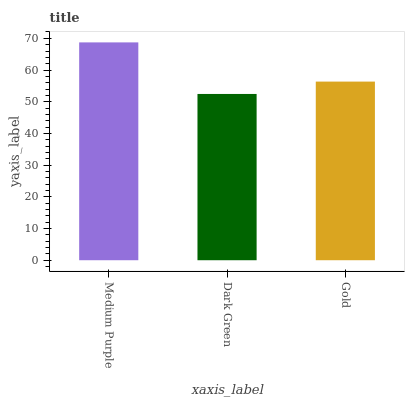Is Dark Green the minimum?
Answer yes or no. Yes. Is Medium Purple the maximum?
Answer yes or no. Yes. Is Gold the minimum?
Answer yes or no. No. Is Gold the maximum?
Answer yes or no. No. Is Gold greater than Dark Green?
Answer yes or no. Yes. Is Dark Green less than Gold?
Answer yes or no. Yes. Is Dark Green greater than Gold?
Answer yes or no. No. Is Gold less than Dark Green?
Answer yes or no. No. Is Gold the high median?
Answer yes or no. Yes. Is Gold the low median?
Answer yes or no. Yes. Is Medium Purple the high median?
Answer yes or no. No. Is Medium Purple the low median?
Answer yes or no. No. 